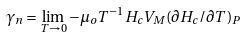<formula> <loc_0><loc_0><loc_500><loc_500>\ \gamma _ { n } = \lim _ { T \rightarrow 0 } - \mu _ { o } T ^ { - 1 } H _ { c } V _ { M } ( \partial H _ { c } / \partial T ) _ { P }</formula> 